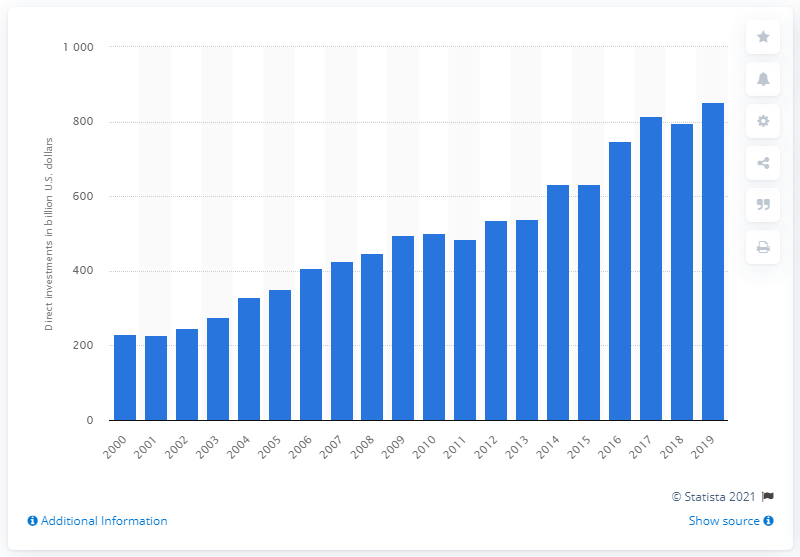Outline some significant characteristics in this image. In 2019, the value of U.S. investments made in the UK was $851.41. 